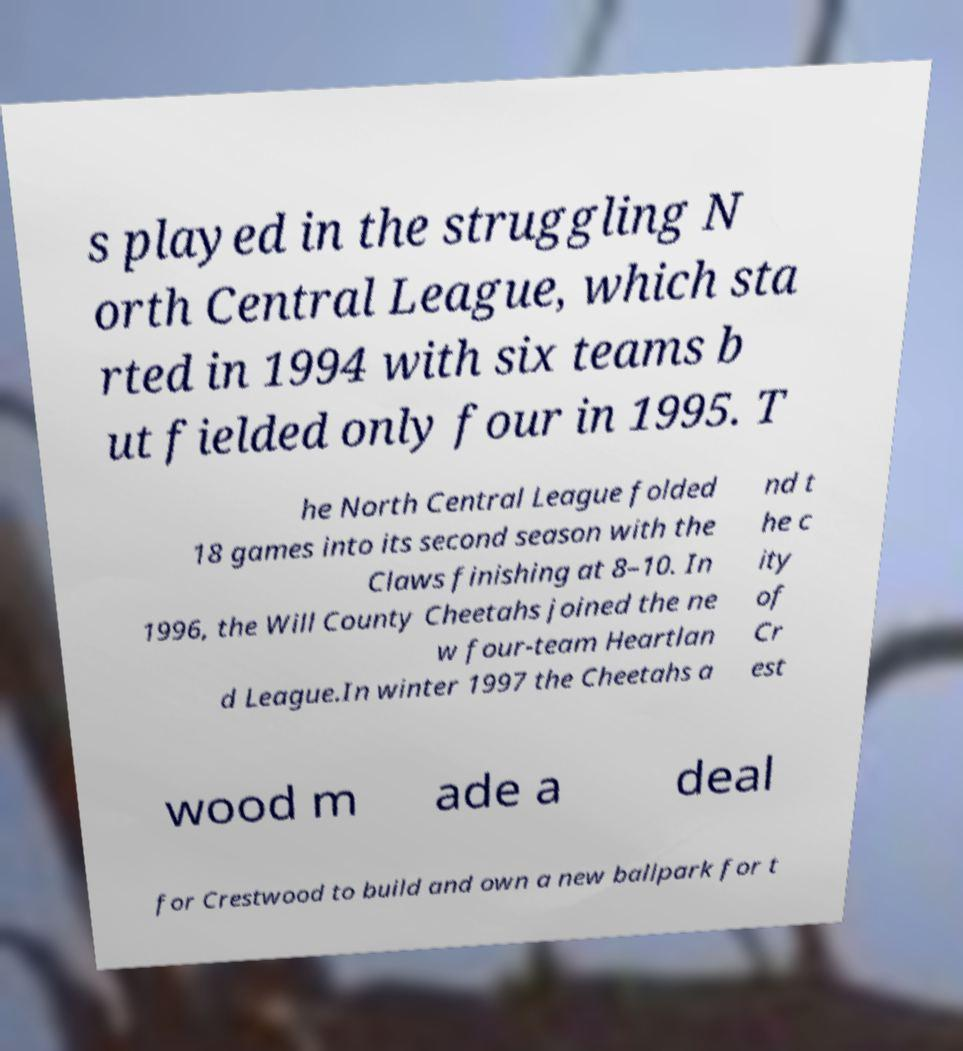What messages or text are displayed in this image? I need them in a readable, typed format. s played in the struggling N orth Central League, which sta rted in 1994 with six teams b ut fielded only four in 1995. T he North Central League folded 18 games into its second season with the Claws finishing at 8–10. In 1996, the Will County Cheetahs joined the ne w four-team Heartlan d League.In winter 1997 the Cheetahs a nd t he c ity of Cr est wood m ade a deal for Crestwood to build and own a new ballpark for t 